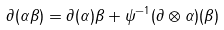<formula> <loc_0><loc_0><loc_500><loc_500>\partial ( \alpha \beta ) = \partial ( \alpha ) \beta + \psi ^ { - 1 } ( \partial \otimes \alpha ) ( \beta )</formula> 